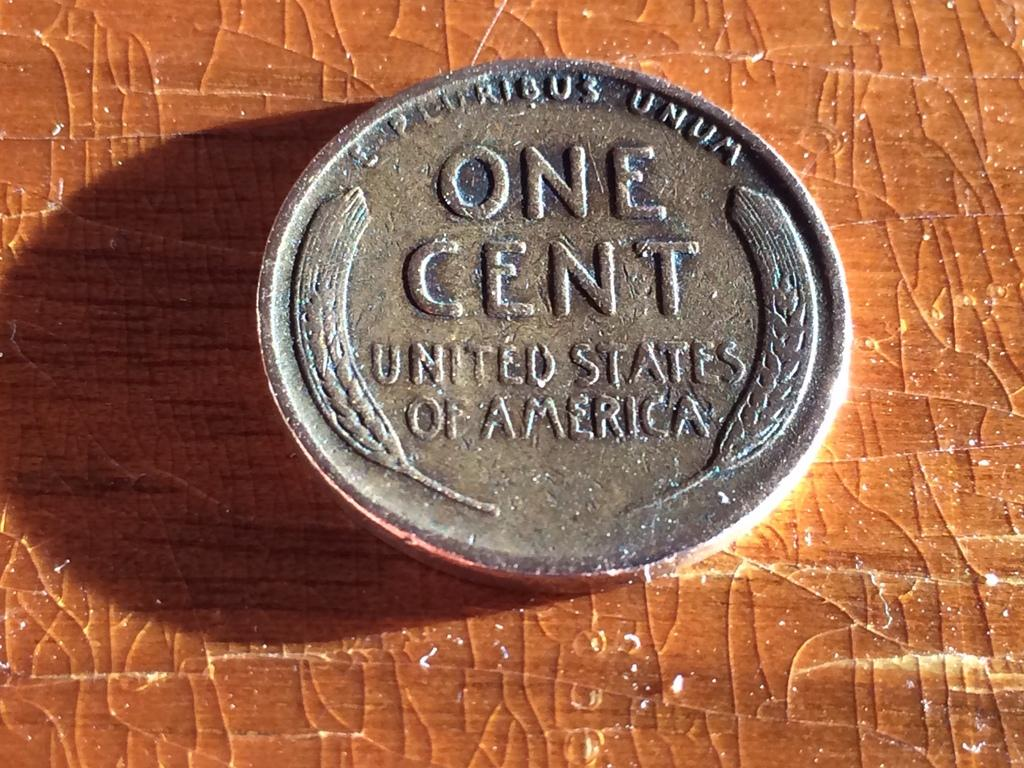<image>
Write a terse but informative summary of the picture. One cent copper penny with United States of America imprinted. 